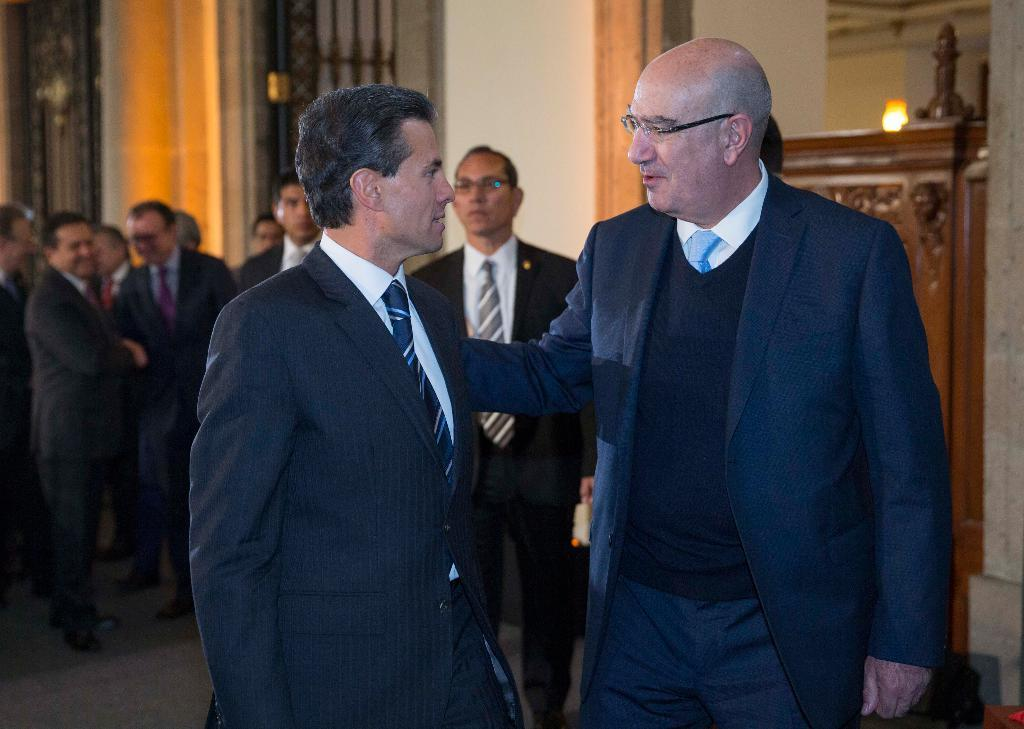Who or what is present in the image? There are people in the image. What can be seen beneath the people's feet? The floor is visible in the image. What is located behind the people? There is a wall in the background of the image. Can you describe the lighting conditions in the image? There is a light in the background of the image. What else can be seen in the background of the image? There are objects in the background of the image. How many pairs of shoes can be seen on the people's feet in the image? There is no information about shoes in the image, so we cannot determine how many pairs are visible. 